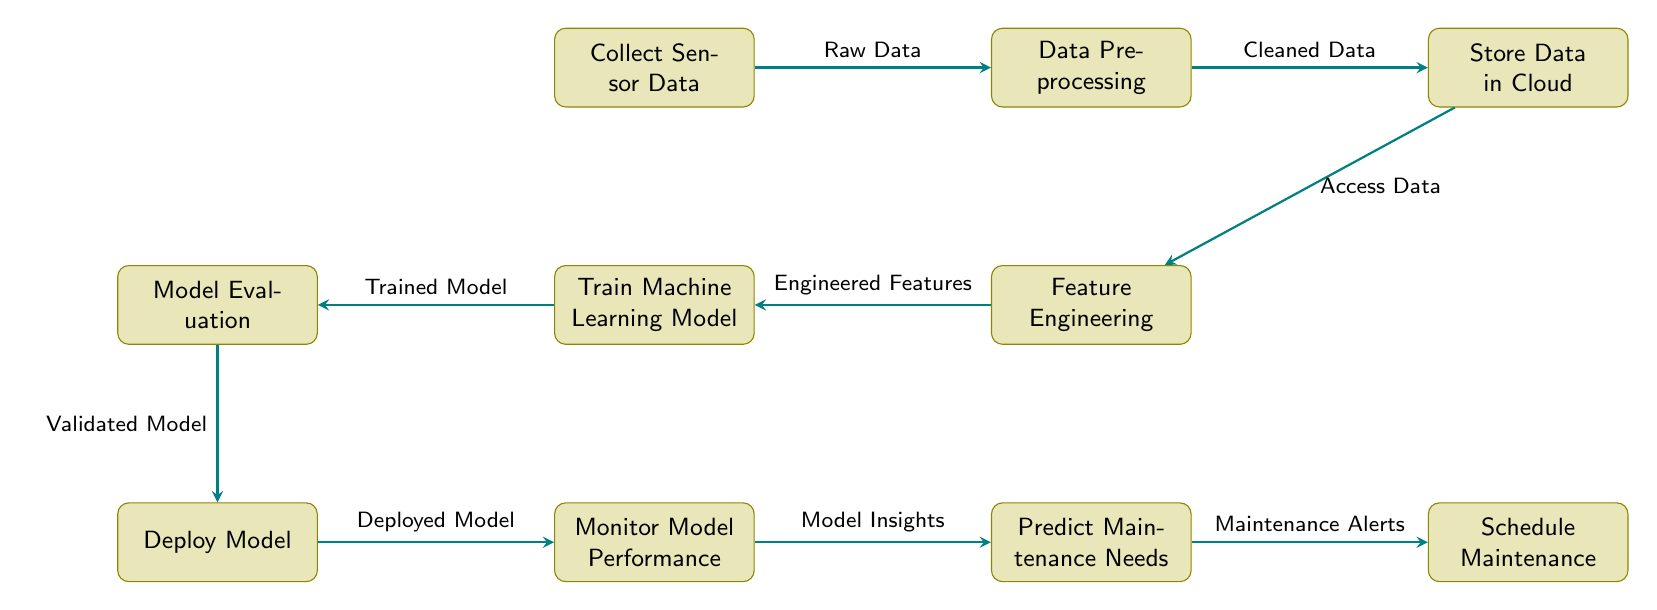What is the first step in the machine learning workflow? The first step is to collect sensor data, as indicated by the top-left node.
Answer: Collect Sensor Data How many main processes are there in the diagram? There are ten main processes represented in the diagram, counting each distinct node.
Answer: 10 What is the output of the “Data Preprocessing” step? The output of the “Data Preprocessing” step is “Cleaned Data,” which is directed to the “Store Data in Cloud” node.
Answer: Cleaned Data Where does the “Feature Engineering” step receive data from? The “Feature Engineering” step receives data from “Stored Data in Cloud,” as indicated by the connection leading into it.
Answer: Store Data in Cloud What action follows the “Deploy Model” step? The action that follows the “Deploy Model” step is “Monitor Model Performance,” which is the next node below it in the workflow.
Answer: Monitor Model Performance What is the role of the “Train Machine Learning Model” step? The role of this step is to produce a “Trained Model,” which is then evaluated in the subsequent step.
Answer: Trained Model Which process leads to the generation of “Maintenance Alerts”? The process that leads to the generation of “Maintenance Alerts” is “Predict Maintenance Needs,” which connects directly to “Schedule Maintenance.”
Answer: Predict Maintenance Needs What connects the "Deploy Model" process to the "Monitor Model Performance"? These processes are connected by the “Deployed Model,” which is the output of the “Deploy Model.”
Answer: Deployed Model What is the relationship between "Evaluate Model" and "Train Machine Learning Model"? The relationship is sequential; "Evaluate Model" follows "Train Machine Learning Model," where the output of training becomes the input for evaluation.
Answer: Sequential relationship What type of data goes into the “Data Preprocessing” step? The type of data entering this step is “Raw Data,” which is collected initially and processed next.
Answer: Raw Data 